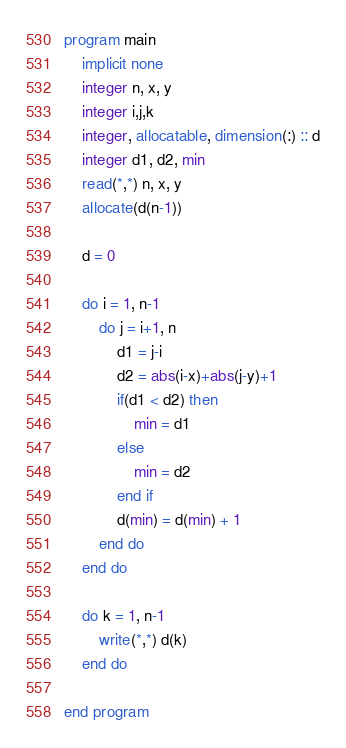Convert code to text. <code><loc_0><loc_0><loc_500><loc_500><_FORTRAN_>program main
    implicit none
    integer n, x, y
    integer i,j,k
    integer, allocatable, dimension(:) :: d
    integer d1, d2, min
    read(*,*) n, x, y
    allocate(d(n-1))

    d = 0

    do i = 1, n-1
        do j = i+1, n
            d1 = j-i
            d2 = abs(i-x)+abs(j-y)+1
            if(d1 < d2) then
                min = d1
            else
                min = d2
            end if
            d(min) = d(min) + 1
        end do
    end do

    do k = 1, n-1
        write(*,*) d(k)
    end do

end program</code> 